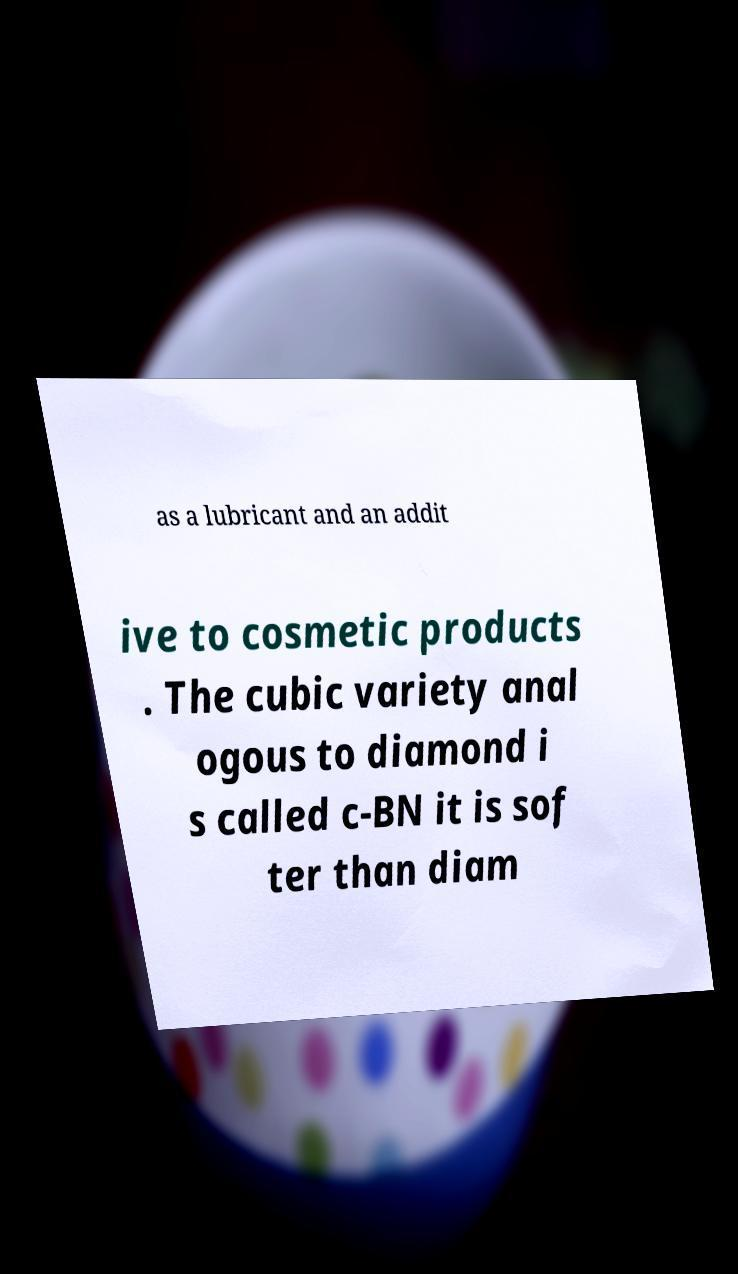For documentation purposes, I need the text within this image transcribed. Could you provide that? as a lubricant and an addit ive to cosmetic products . The cubic variety anal ogous to diamond i s called c-BN it is sof ter than diam 